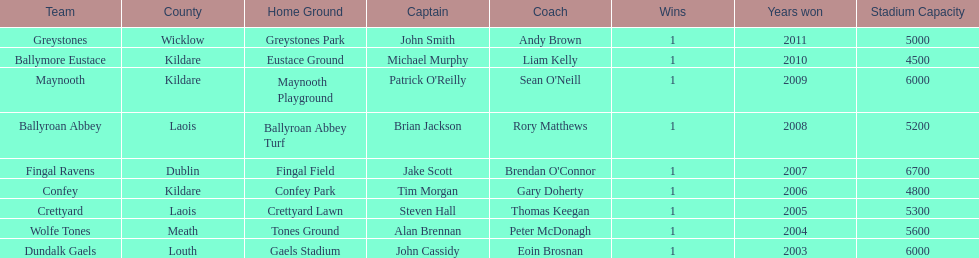Which team won after ballymore eustace? Greystones. 